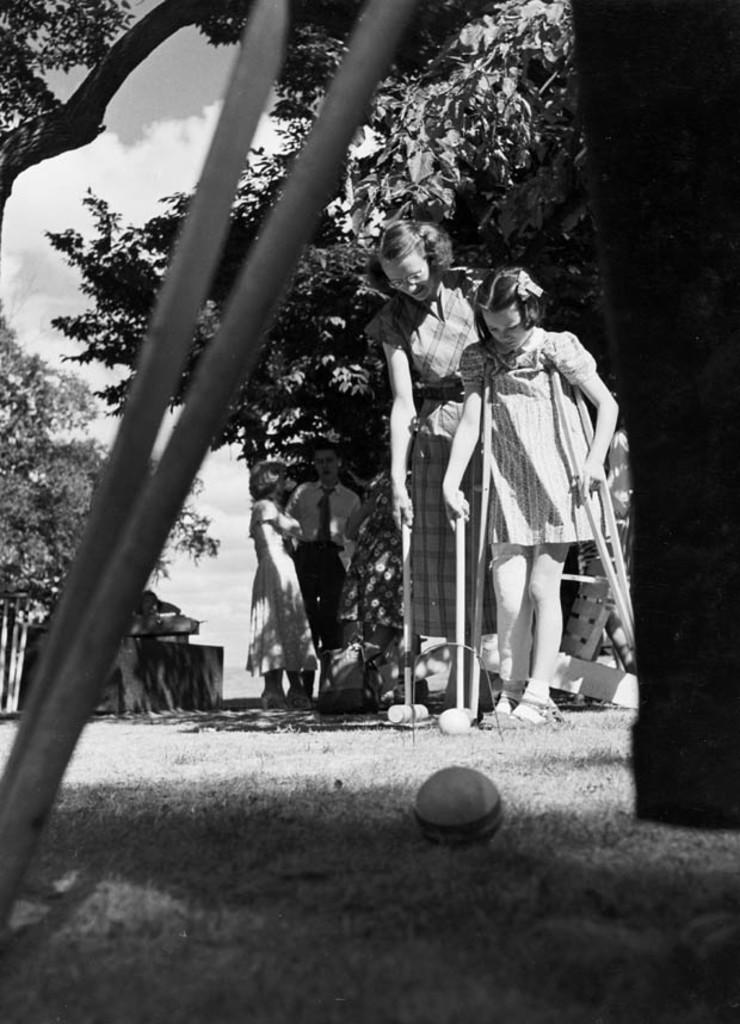How many people are in the image? There are people in the image, but the exact number is not specified. Can you describe the girl on the left side of the image? The girl on the left side of the image is standing and holding walking sticks. What type of terrain is visible at the bottom of the image? There is grass at the bottom of the image. What can be seen in the background of the image? There are trees and the sky visible in the background of the image. How many beds are visible in the image? There are no beds present in the image. What is the relation between the people in the image? The facts provided do not give any information about the relationship between the people in the image. 